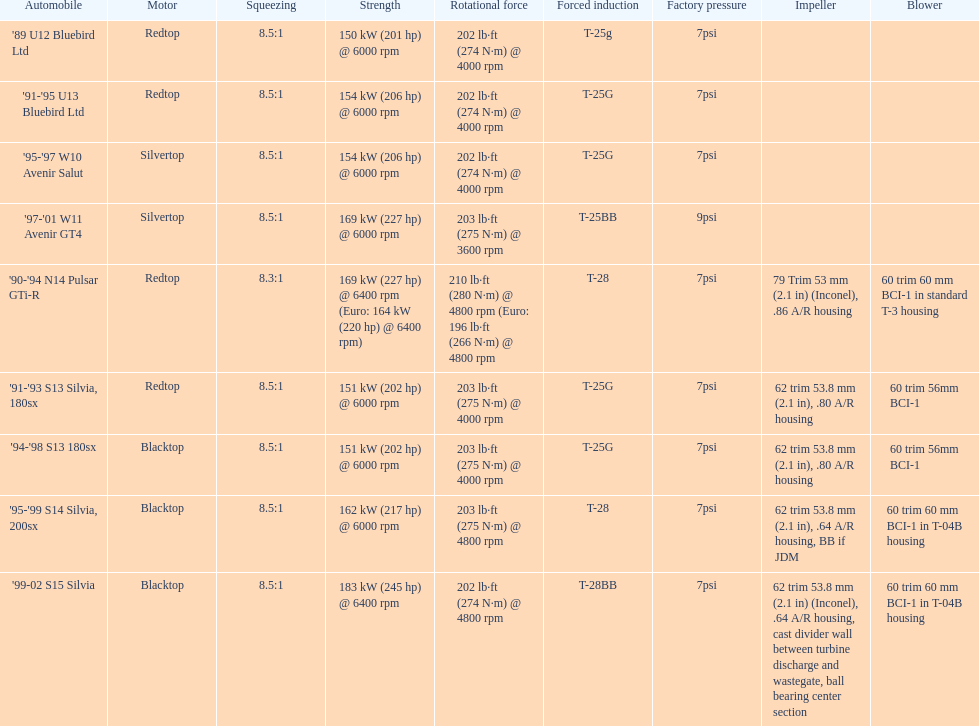Which car possesses an original boost exceeding 7psi? '97-'01 W11 Avenir GT4. 